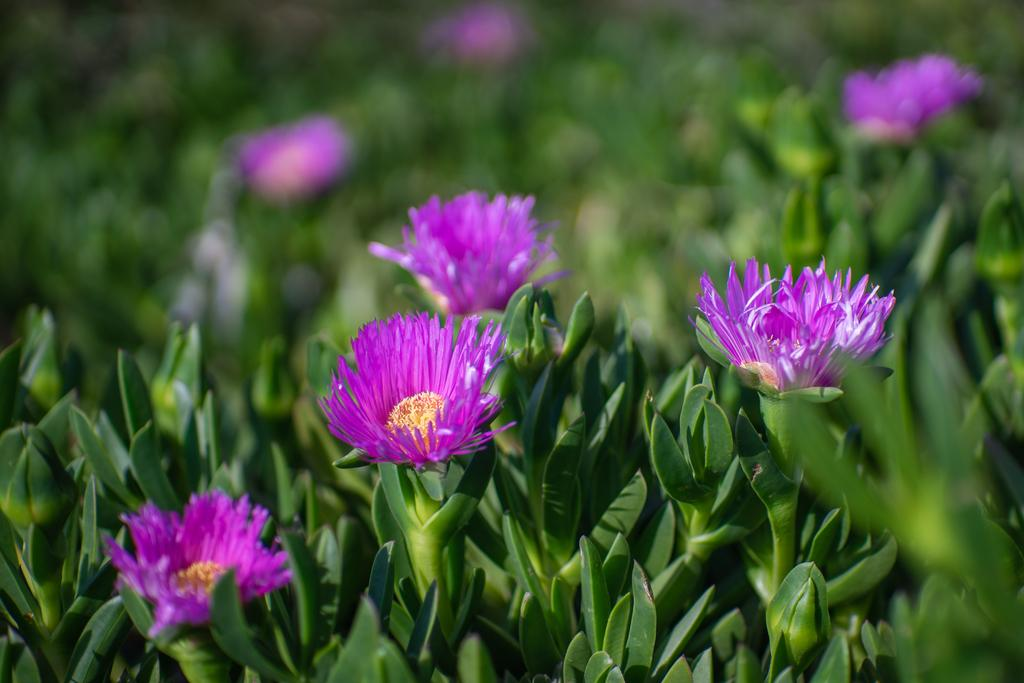What is the main subject of the image? The main subject of the image is a group of plants. What can be observed about the plants in the image? The plants have flowers. How many toes can be seen on the plants in the image? There are no toes present in the image, as it features plants with flowers. 